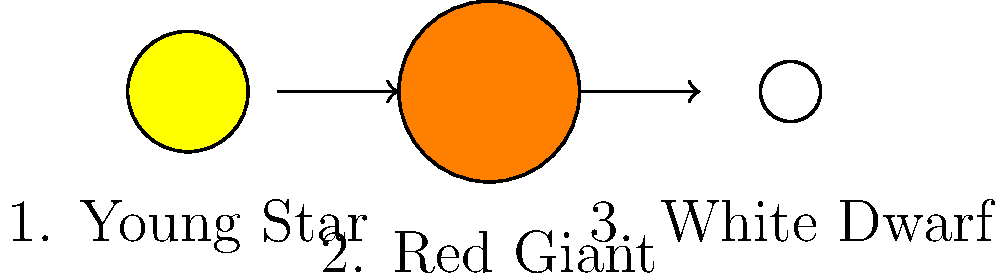In the illustration above, which stage of a star's life cycle comes after the Red Giant phase? Let's break down the life cycle of a star as shown in the illustration:

1. The first stage shows a young star, which is small and bright yellow.
2. The second stage depicts a Red Giant, which is larger and orange in color. This happens when a star runs out of hydrogen to fuse in its core and expands.
3. The final stage shown is a White Dwarf, which is smaller and white in color.

After a star becomes a Red Giant, it will eventually shed its outer layers. What's left behind is the hot, dense core of the star, which we call a White Dwarf. This is the final stage for stars like our Sun.

So, according to this simplified life cycle, the stage that comes after the Red Giant phase is the White Dwarf stage.
Answer: White Dwarf 